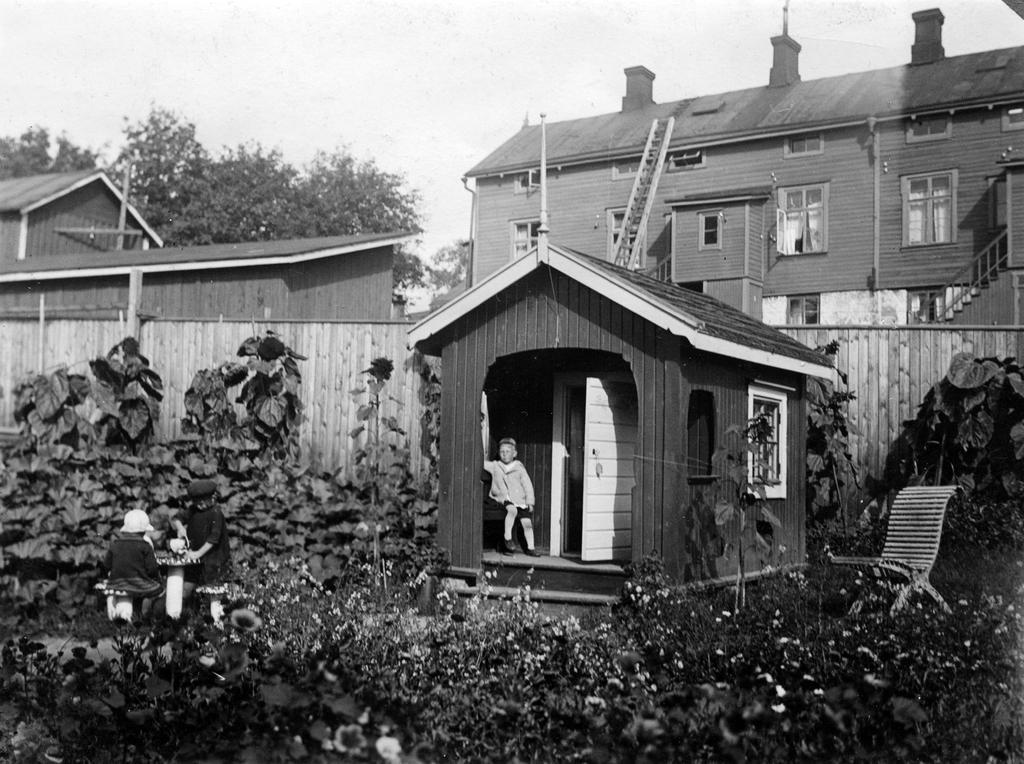In one or two sentences, can you explain what this image depicts? It is a black and white image there is a small hut and in front of the hut there is a kid and there are many plants in the garden outside the hut and on the left side there are two kids. Behind the hut there are some other wooden buildings and trees. 